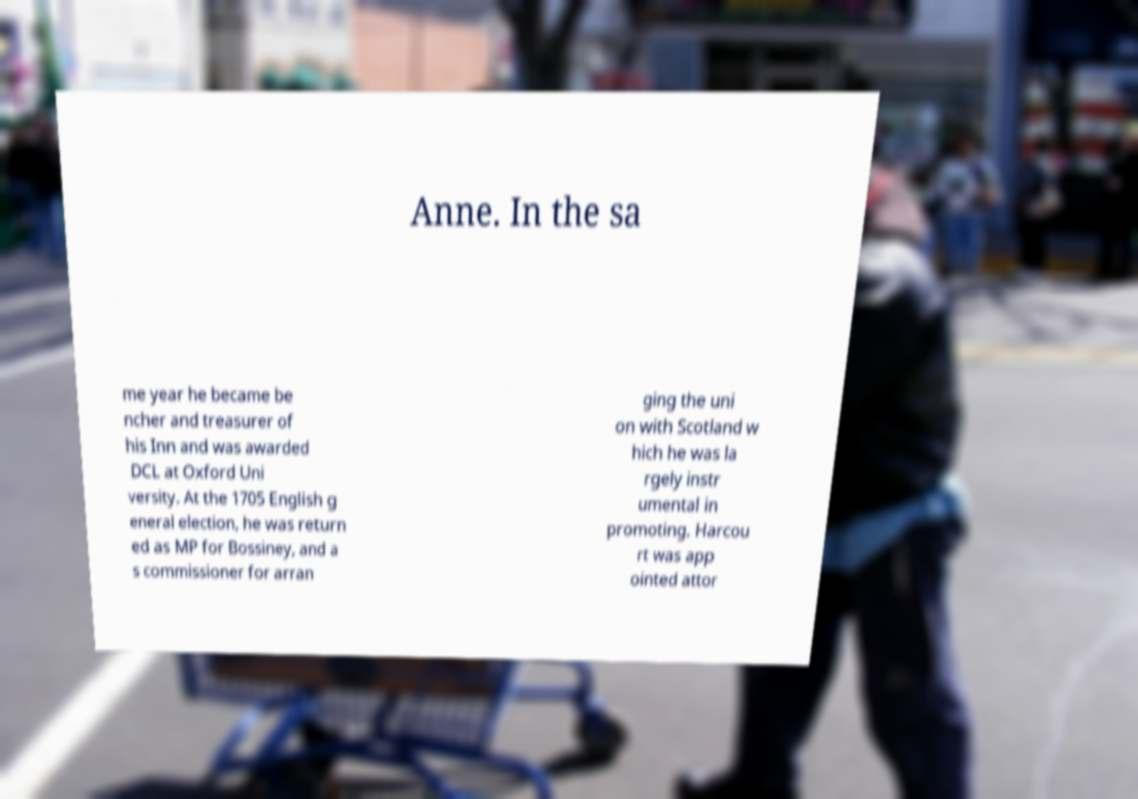Can you accurately transcribe the text from the provided image for me? Anne. In the sa me year he became be ncher and treasurer of his Inn and was awarded DCL at Oxford Uni versity. At the 1705 English g eneral election, he was return ed as MP for Bossiney, and a s commissioner for arran ging the uni on with Scotland w hich he was la rgely instr umental in promoting. Harcou rt was app ointed attor 